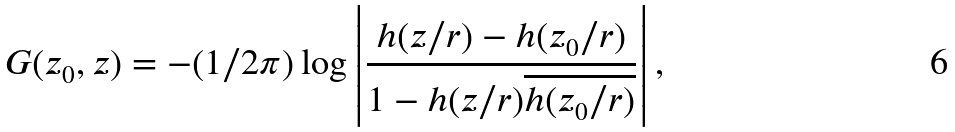Convert formula to latex. <formula><loc_0><loc_0><loc_500><loc_500>G ( z _ { 0 } , z ) = - ( 1 / 2 \pi ) \log \left | \frac { h ( z / r ) - h ( z _ { 0 } / r ) } { 1 - h ( z / r ) \overline { h ( z _ { 0 } / r ) } } \right | ,</formula> 